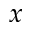<formula> <loc_0><loc_0><loc_500><loc_500>x</formula> 